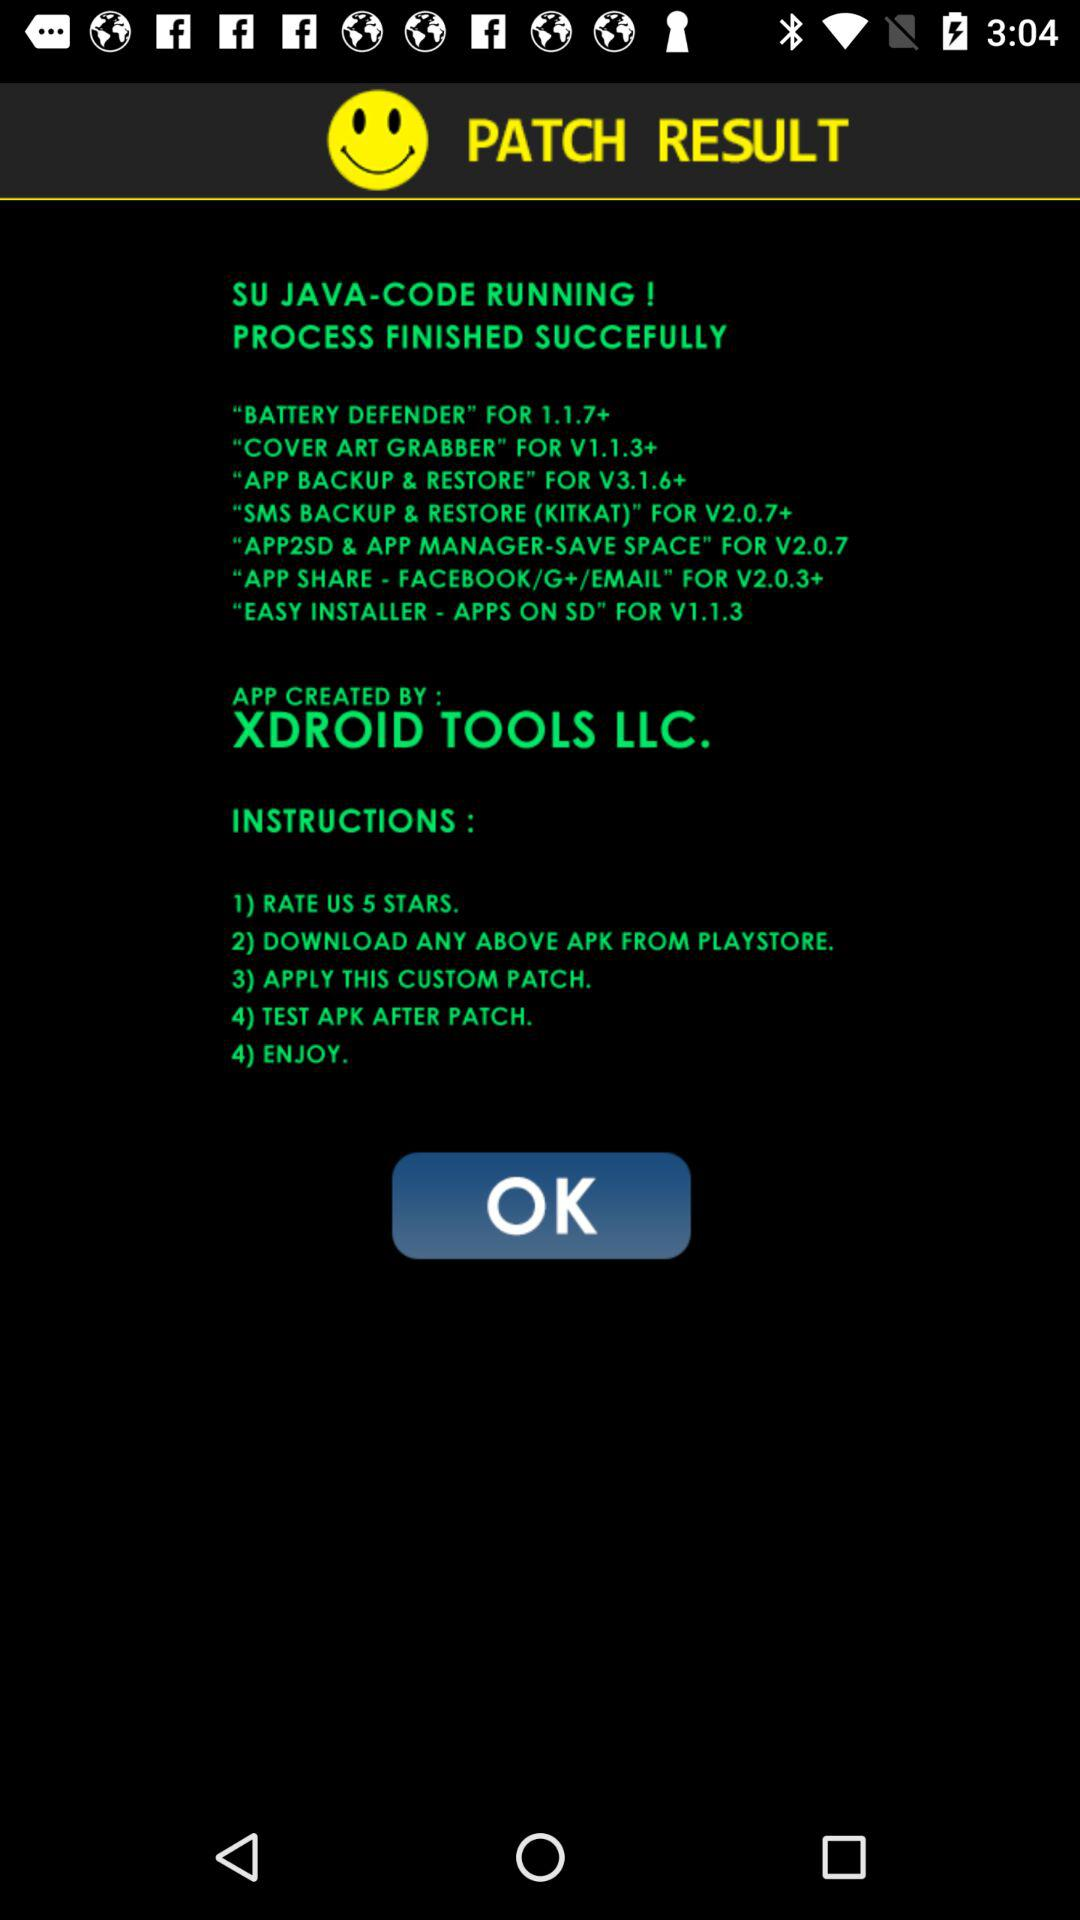What is the application name? The application name is "PATCH RESULT". 